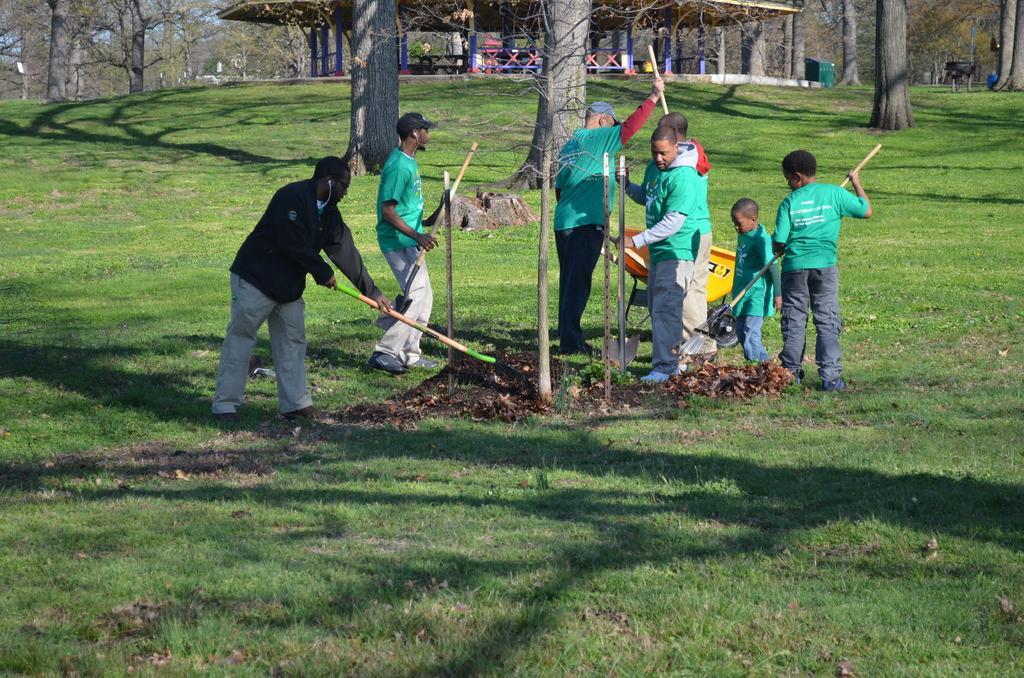In one or two sentences, can you explain what this image depicts? This is the picture of a park. In this image there are group of people standing and holding the tools and there is a trolley. At the back there is a hut and there are trees. At the top there is sky. At the bottom there is grass. 